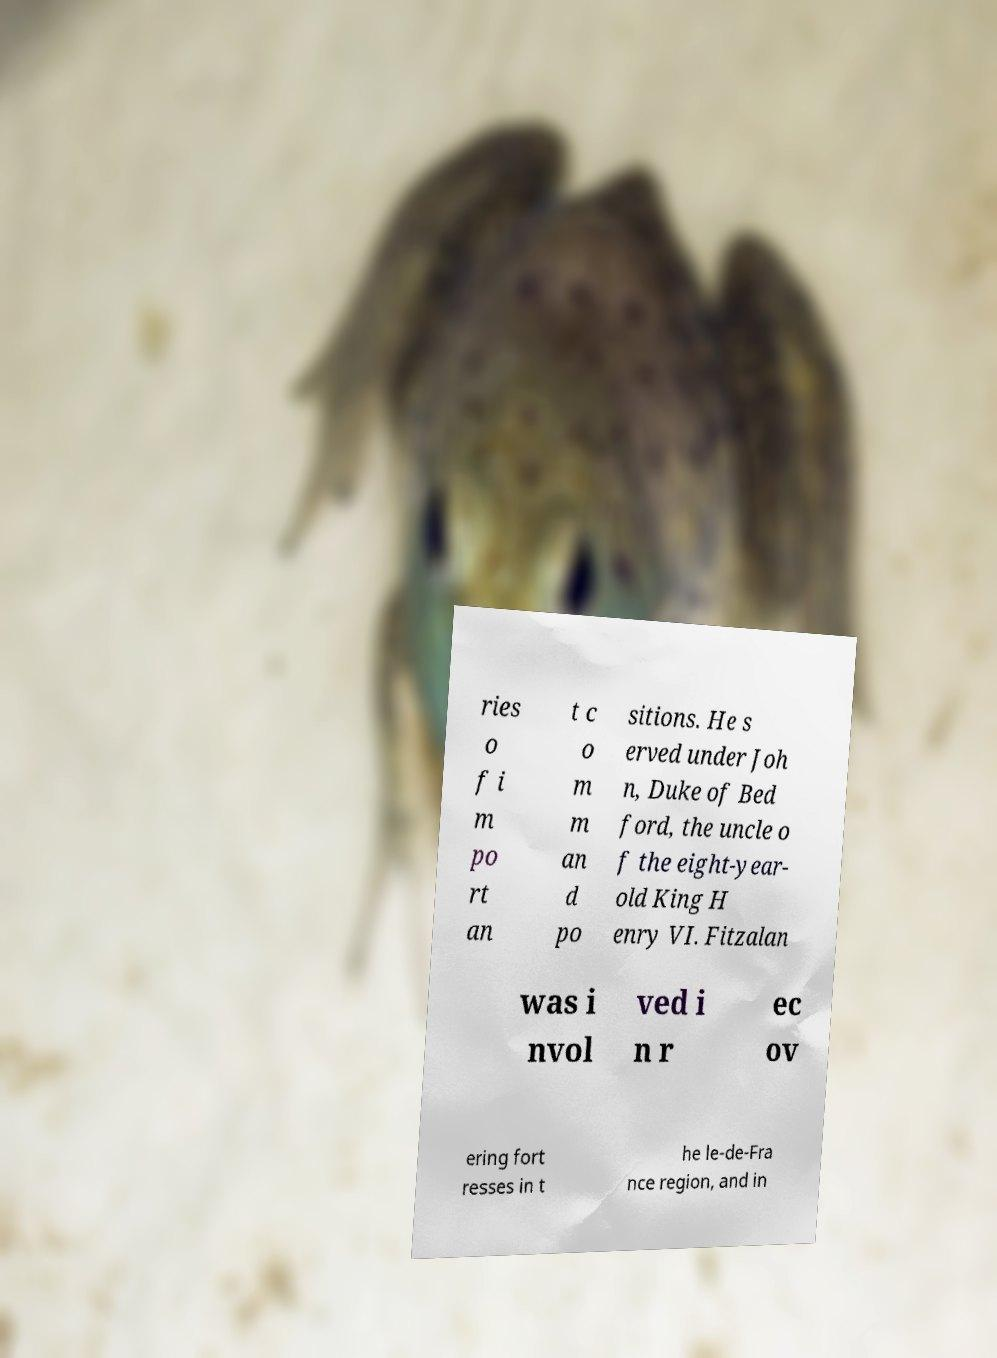There's text embedded in this image that I need extracted. Can you transcribe it verbatim? ries o f i m po rt an t c o m m an d po sitions. He s erved under Joh n, Duke of Bed ford, the uncle o f the eight-year- old King H enry VI. Fitzalan was i nvol ved i n r ec ov ering fort resses in t he le-de-Fra nce region, and in 